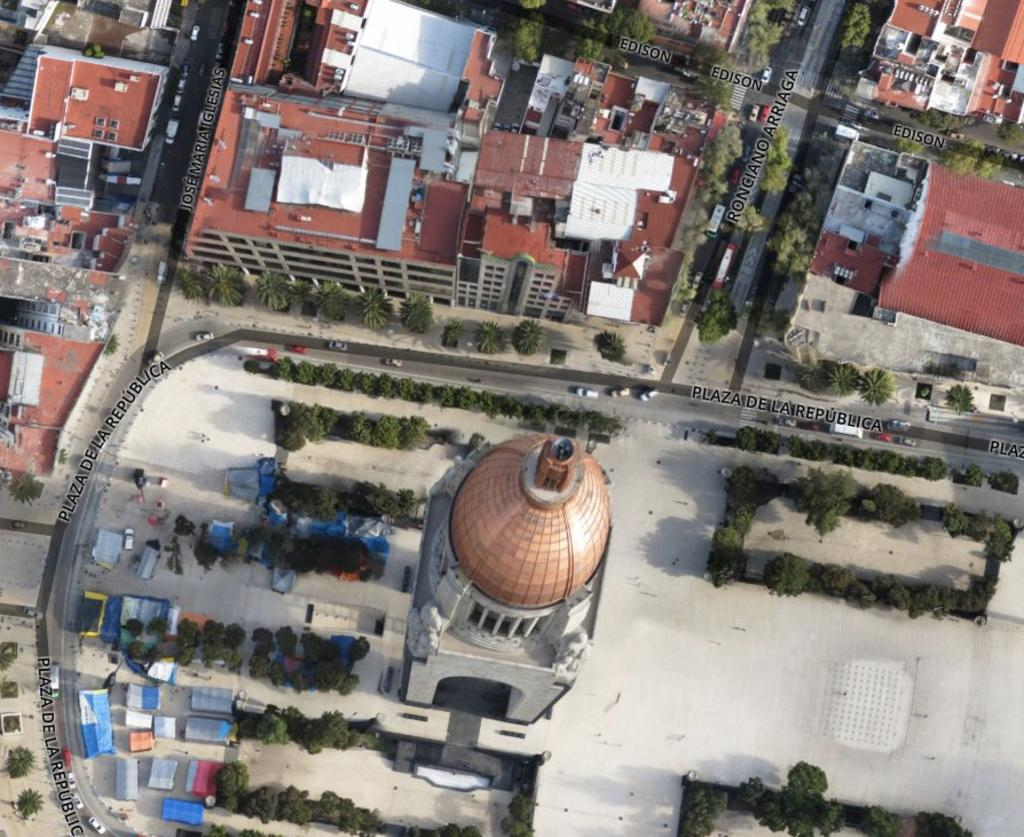What is the perspective of the image? The image is a top view of a city. What type of vegetation can be seen in the city? There are small plants and trees in the city. What type of structures are present in the city? There are buildings in the city. What type of transportation is visible in the city? There are vehicles in the city. What direction are the quivers pointing in the image? There are no quivers present in the image. What type of test is being conducted in the city in the image? There is no test being conducted in the city in the image. 